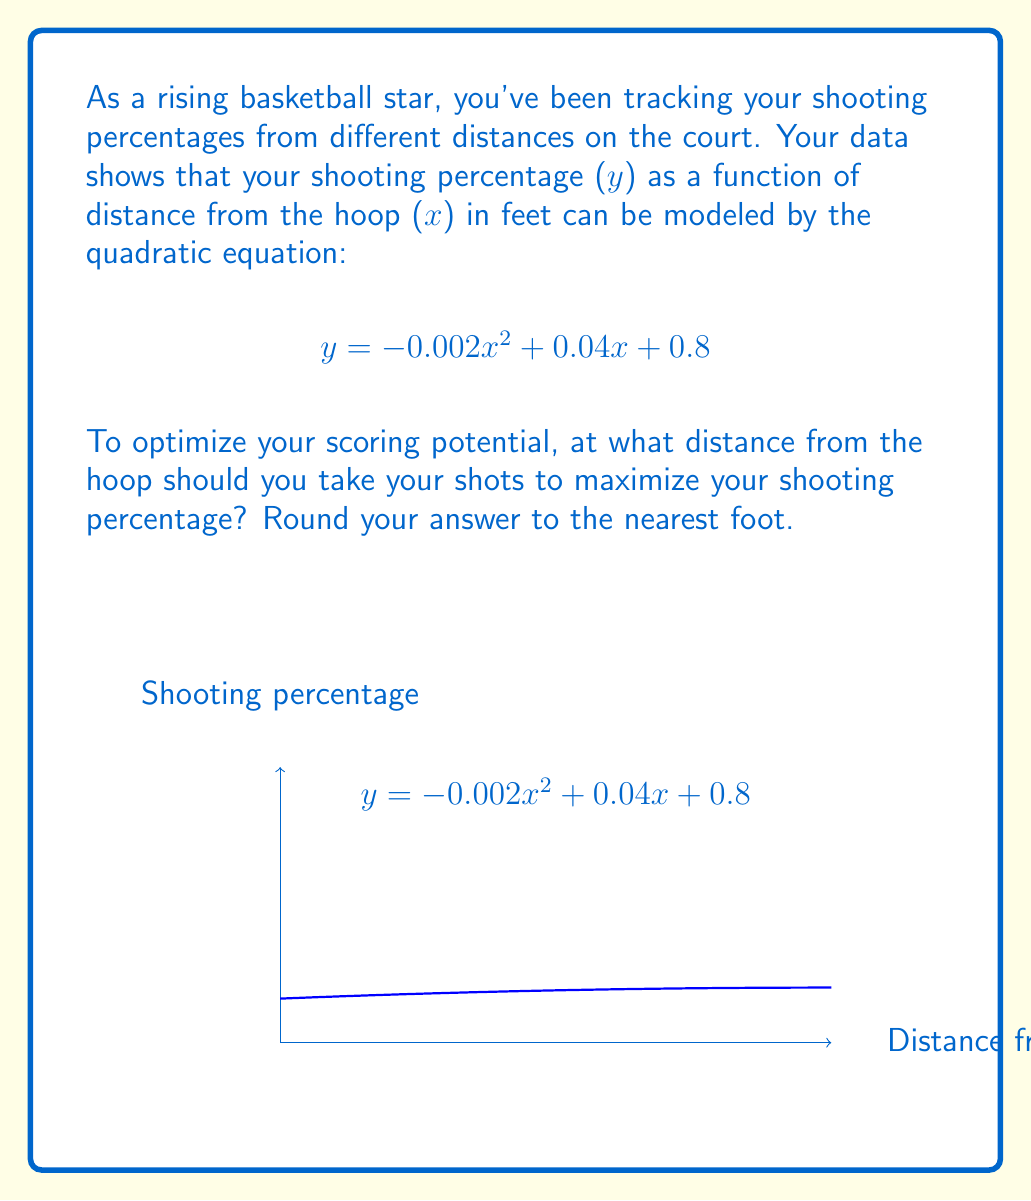What is the answer to this math problem? To find the maximum of a quadratic function, we need to follow these steps:

1) The general form of a quadratic function is $f(x) = ax^2 + bx + c$. In this case:
   $a = -0.002$, $b = 0.04$, and $c = 0.8$

2) The x-coordinate of the vertex of a parabola (which gives the maximum for a downward-facing parabola) is given by the formula:

   $$x = -\frac{b}{2a}$$

3) Let's substitute our values:

   $$x = -\frac{0.04}{2(-0.002)} = \frac{0.04}{0.004} = 10$$

4) Therefore, the maximum shooting percentage occurs at 10 feet from the hoop.

5) To verify, we can calculate the y-value at this point:

   $$y = -0.002(10)^2 + 0.04(10) + 0.8$$
   $$= -0.2 + 0.4 + 0.8 = 1$$

   This confirms that 10 feet gives the highest point on the parabola.

6) The question asks to round to the nearest foot, but 10 is already a whole number, so no rounding is necessary.
Answer: 10 feet 